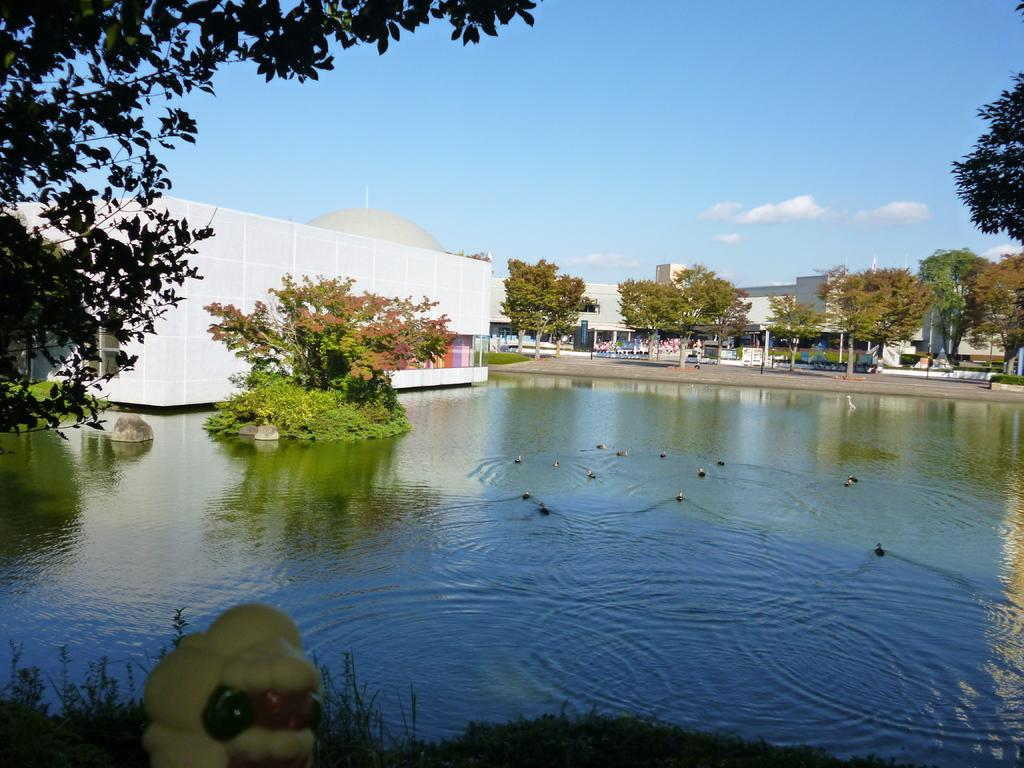What is the main subject in the center of the image? There is water in the center of the image. What can be seen in the distance behind the water? There are buildings and trees in the background of the image. What grade does the ant receive for its performance in the image? There is no ant present in the image, so it cannot receive a grade. 